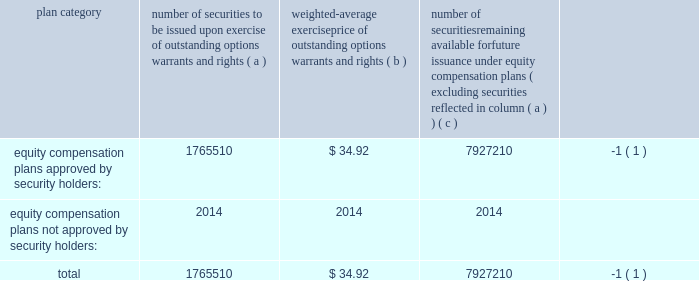Item 11 2014executive compensation we incorporate by reference in this item 11 the information relating to executive and director compensation contained under the headings 201cother information about the board and its committees , 201d 201ccompensation and other benefits 201d and 201creport of the compensation committee 201d from our proxy statement to be delivered in connection with our 2013 annual meeting of shareholders to be held on november 20 , 2013 .
Item 12 2014security ownership of certain beneficial owners and management and related stockholder matters we incorporate by reference in this item 12 the information relating to ownership of our common stock by certain persons contained under the headings 201ccommon stock ownership of management 201d and 201ccommon stock ownership by certain other persons 201d from our proxy statement to be delivered in connection with our 2013 annual meeting of shareholders to be held on november 20 , 2013 .
The table provides certain information as of may 31 , 2013 concerning the shares of the company 2019s common stock that may be issued under existing equity compensation plans .
For more information on these plans , see note 11 to notes to consolidated financial statements .
Plan category number of securities to be issued upon exercise of outstanding options , warrants and rights weighted- average exercise price of outstanding options , warrants and rights number of securities remaining available for future issuance under equity compensation plans ( excluding securities reflected in column ( a ) ) equity compensation plans approved by security holders : 1765510 $ 34.92 7927210 ( 1 ) equity compensation plans not approved by security holders : 2014 2014 2014 .
( 1 ) also includes shares of common stock available for issuance other than upon the exercise of an option , warrant or right under the global payments inc .
2000 long-term incentive plan , as amended and restated , the global payments inc .
Amended and restated 2005 incentive plan , amended and restated 2000 non- employee director stock option plan , global payments employee stock purchase plan and the global payments inc .
2011 incentive plan .
Item 13 2014certain relationships and related transactions , and director independence we incorporate by reference in this item 13 the information regarding certain relationships and related transactions between us and some of our affiliates and the independence of our board of directors contained under the headings 201ccertain relationships and related transactions 201d and 201cother information about the board and its committees 201d from our proxy statement to be delivered in connection with our 2013 annual meeting of shareholders to be held on november 20 , 2013 .
Item 14 2014principal accounting fees and services we incorporate by reference in this item 14 the information regarding principal accounting fees and services contained under the section ratification of the reappointment of auditors from our proxy statement to be delivered in connection with our 2013 annual meeting of shareholders to be held on november 20 , 2013. .
If the company were to buy the remaining securities at the average price of $ 34.92 , what would be the total payments from the company? 
Rationale: the payment of the remaining securities can be found by multiplying the number of remaining securities at the average price they are bought .
Computations: (7927210 * 34.92)
Answer: 276818173.2. 